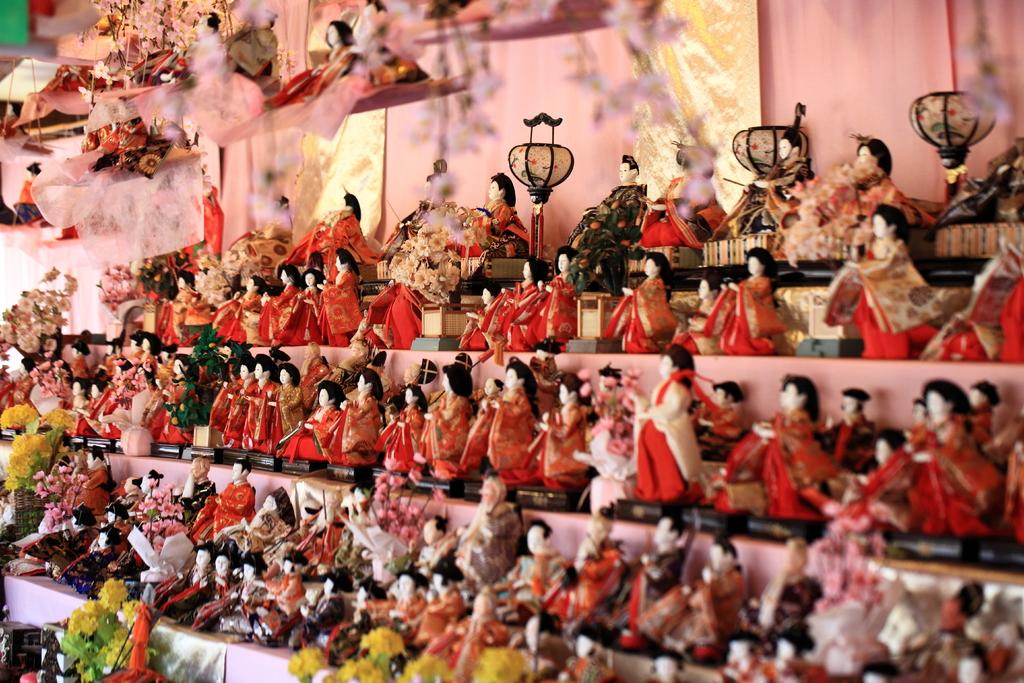What is the main subject of the image? The main subject of the image is a bunch of toys. Are there any other objects or elements near the toys? Yes, there are flowers near the toys. How are some of the toys positioned in the image? Some toys are hanging in the image. How many children are playing with the toys in the image? There are no children present in the image; it only shows a bunch of toys and flowers. 